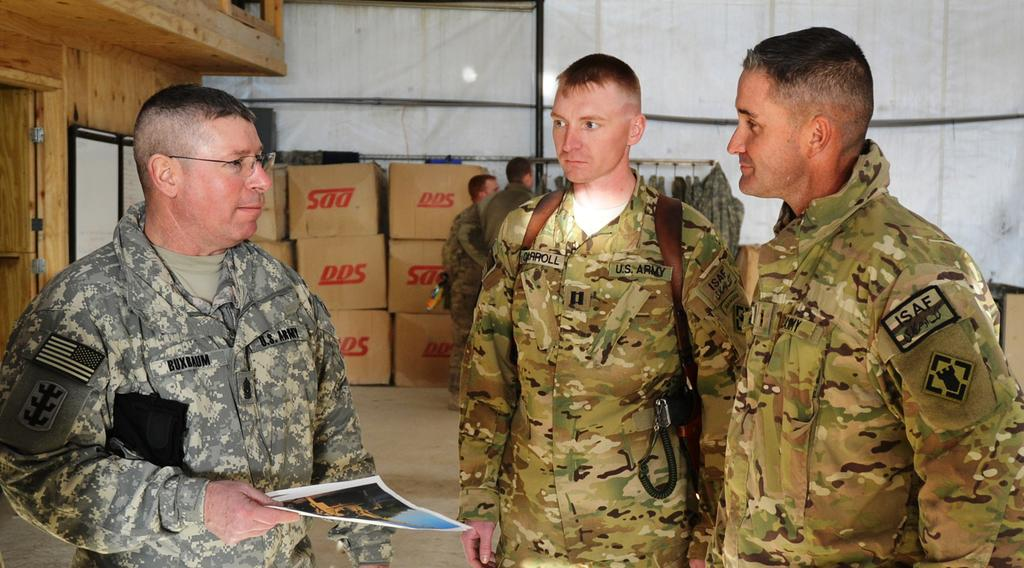What is happening in the image? There are people standing in the image. What is the man holding in the image? The man is holding papers in the image. What can be seen in the background of the image? There is a wooden house, cardboard boxes, and clothes on a hanger in the background of the image. What type of pipe is being used by the people in the image? There is no pipe visible in the image. What is the aftermath of the event depicted in the image? The image does not depict an event, so there is no aftermath to describe. 